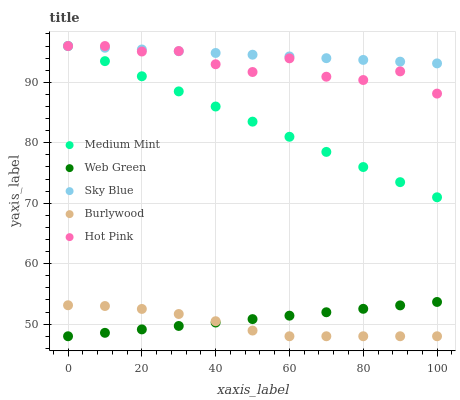Does Burlywood have the minimum area under the curve?
Answer yes or no. Yes. Does Sky Blue have the maximum area under the curve?
Answer yes or no. Yes. Does Hot Pink have the minimum area under the curve?
Answer yes or no. No. Does Hot Pink have the maximum area under the curve?
Answer yes or no. No. Is Web Green the smoothest?
Answer yes or no. Yes. Is Hot Pink the roughest?
Answer yes or no. Yes. Is Sky Blue the smoothest?
Answer yes or no. No. Is Sky Blue the roughest?
Answer yes or no. No. Does Burlywood have the lowest value?
Answer yes or no. Yes. Does Hot Pink have the lowest value?
Answer yes or no. No. Does Hot Pink have the highest value?
Answer yes or no. Yes. Does Burlywood have the highest value?
Answer yes or no. No. Is Burlywood less than Sky Blue?
Answer yes or no. Yes. Is Sky Blue greater than Burlywood?
Answer yes or no. Yes. Does Burlywood intersect Web Green?
Answer yes or no. Yes. Is Burlywood less than Web Green?
Answer yes or no. No. Is Burlywood greater than Web Green?
Answer yes or no. No. Does Burlywood intersect Sky Blue?
Answer yes or no. No. 